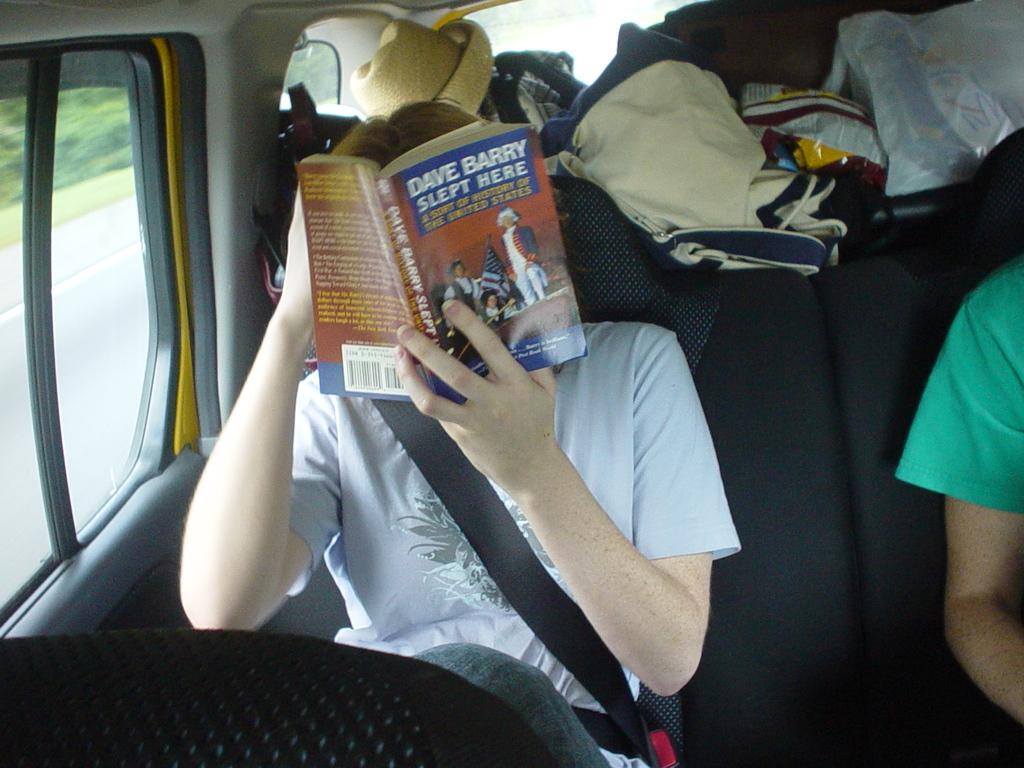What book is he reading?
Your response must be concise. Dave barry slept here. Who is the author of the book the boy is reading?
Ensure brevity in your answer.  Dave barry. 